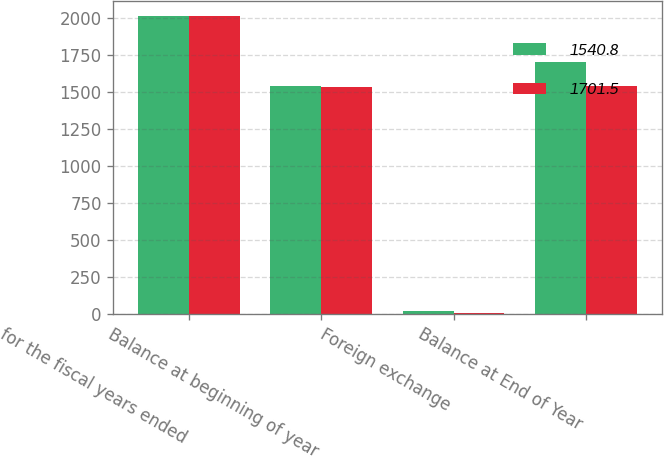Convert chart. <chart><loc_0><loc_0><loc_500><loc_500><stacked_bar_chart><ecel><fcel>for the fiscal years ended<fcel>Balance at beginning of year<fcel>Foreign exchange<fcel>Balance at End of Year<nl><fcel>1540.8<fcel>2013<fcel>1540.8<fcel>20.9<fcel>1701.5<nl><fcel>1701.5<fcel>2012<fcel>1536.2<fcel>4.6<fcel>1540.8<nl></chart> 